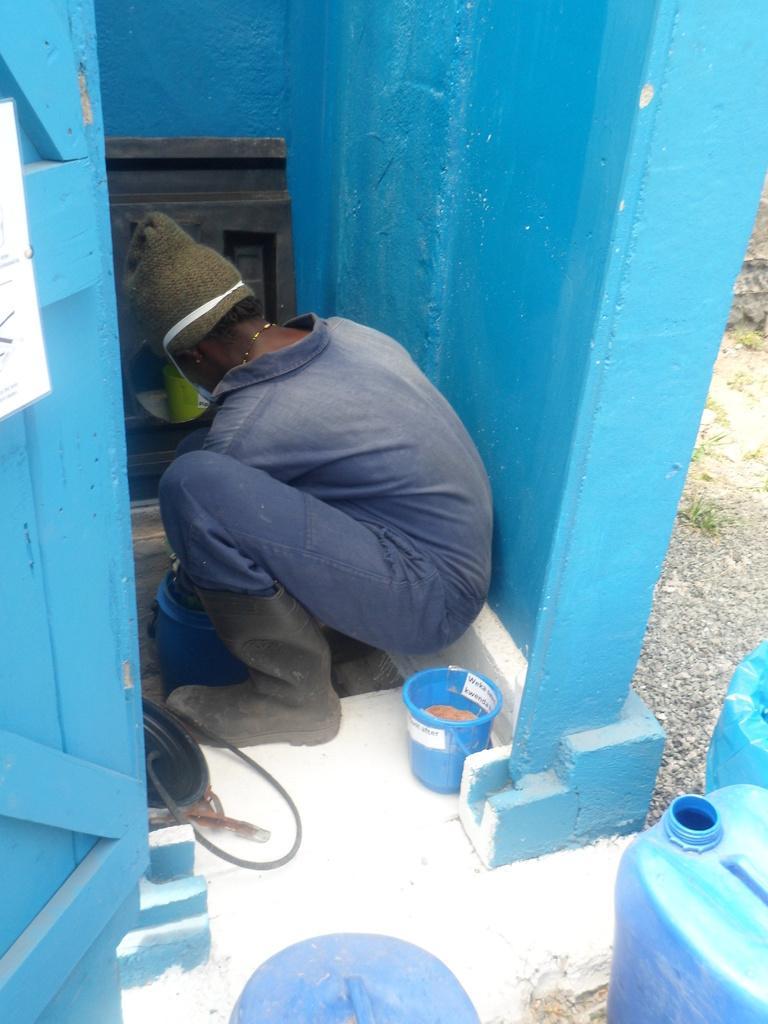Can you describe this image briefly? In this image there is a person, bucket, cans, wall and objects. 